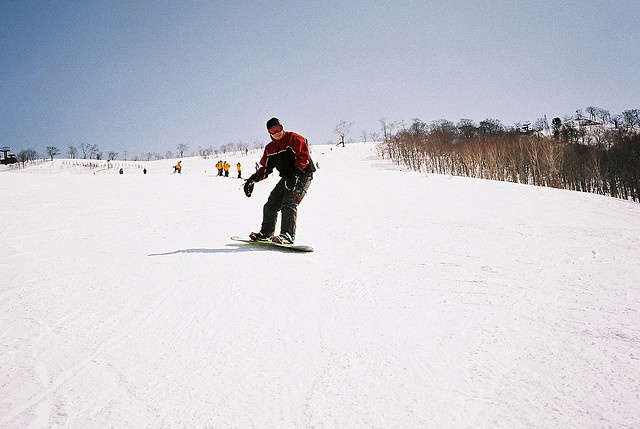Describe the objects in this image and their specific colors. I can see people in gray, black, maroon, and white tones, snowboard in gray, black, darkgreen, and darkgray tones, people in gray, white, black, orange, and red tones, people in gray, black, orange, and red tones, and people in gray, black, orange, red, and maroon tones in this image. 